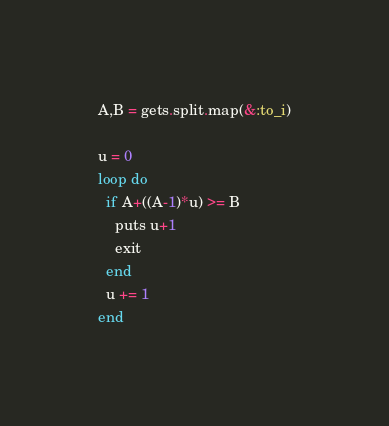<code> <loc_0><loc_0><loc_500><loc_500><_Ruby_>A,B = gets.split.map(&:to_i)

u = 0
loop do
  if A+((A-1)*u) >= B
    puts u+1
    exit
  end
  u += 1
end</code> 